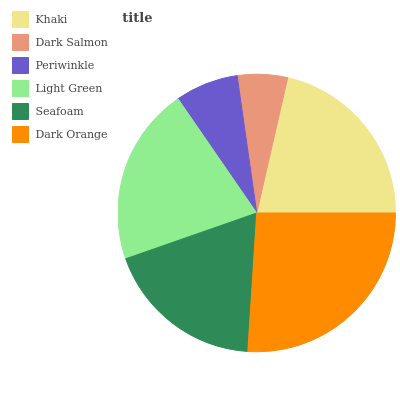Is Dark Salmon the minimum?
Answer yes or no. Yes. Is Dark Orange the maximum?
Answer yes or no. Yes. Is Periwinkle the minimum?
Answer yes or no. No. Is Periwinkle the maximum?
Answer yes or no. No. Is Periwinkle greater than Dark Salmon?
Answer yes or no. Yes. Is Dark Salmon less than Periwinkle?
Answer yes or no. Yes. Is Dark Salmon greater than Periwinkle?
Answer yes or no. No. Is Periwinkle less than Dark Salmon?
Answer yes or no. No. Is Light Green the high median?
Answer yes or no. Yes. Is Seafoam the low median?
Answer yes or no. Yes. Is Seafoam the high median?
Answer yes or no. No. Is Dark Orange the low median?
Answer yes or no. No. 